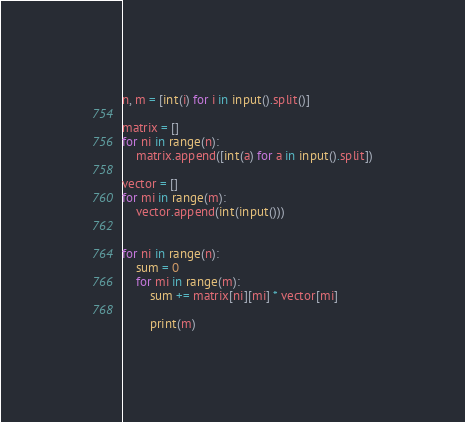<code> <loc_0><loc_0><loc_500><loc_500><_Python_>n, m = [int(i) for i in input().split()]

matrix = []
for ni in range(n):
    matrix.append([int(a) for a in input().split])

vector = []
for mi in range(m):
    vector.append(int(input()))


for ni in range(n):
    sum = 0
    for mi in range(m):
        sum += matrix[ni][mi] * vector[mi]
        
        print(m)</code> 